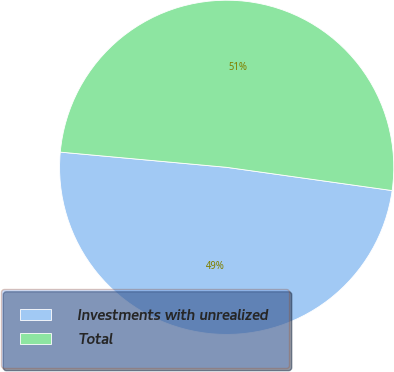Convert chart. <chart><loc_0><loc_0><loc_500><loc_500><pie_chart><fcel>Investments with unrealized<fcel>Total<nl><fcel>49.23%<fcel>50.77%<nl></chart> 